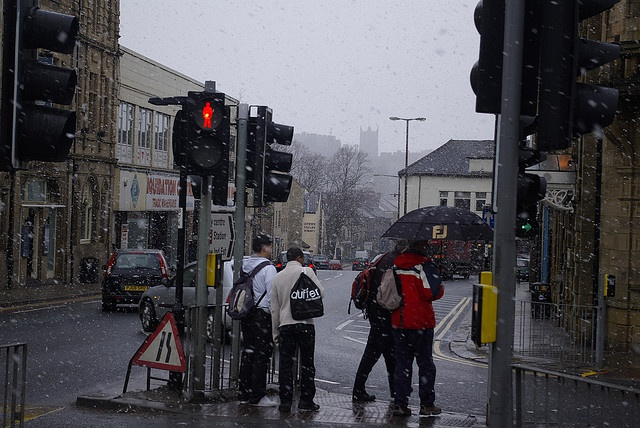Describe the objects in this image and their specific colors. I can see traffic light in gray and black tones, people in gray, black, and maroon tones, people in gray and black tones, people in gray, black, and darkgray tones, and people in gray, black, and maroon tones in this image. 